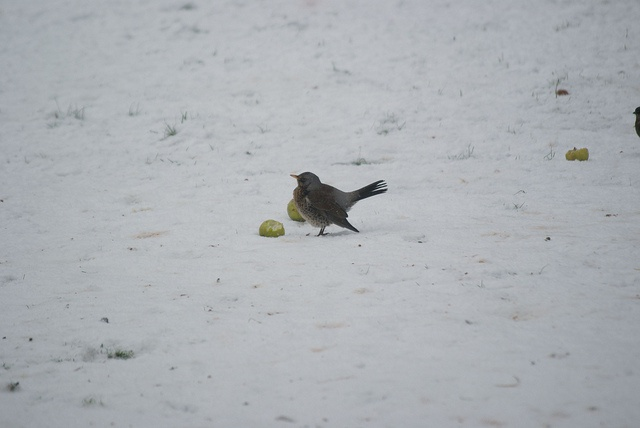Describe the objects in this image and their specific colors. I can see bird in darkgray, black, and gray tones, apple in darkgray and olive tones, apple in darkgray, olive, and gray tones, and bird in darkgray, black, gray, and darkgreen tones in this image. 